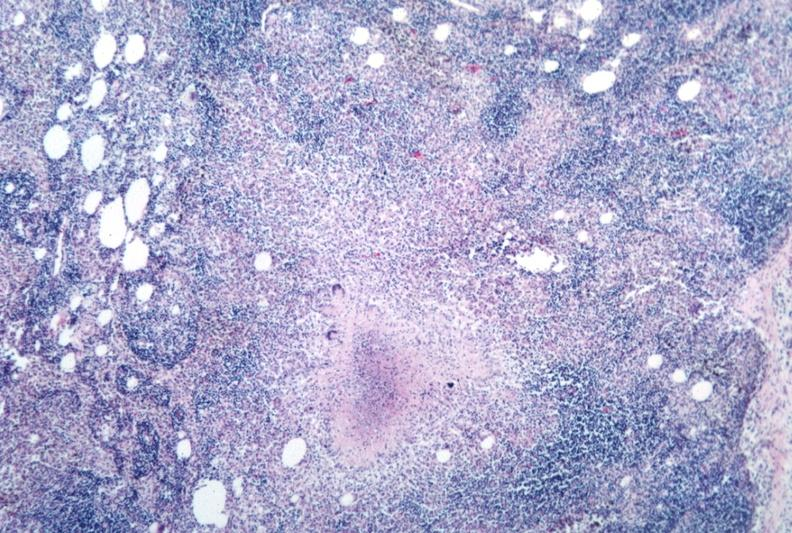s tuberculosis present?
Answer the question using a single word or phrase. Yes 